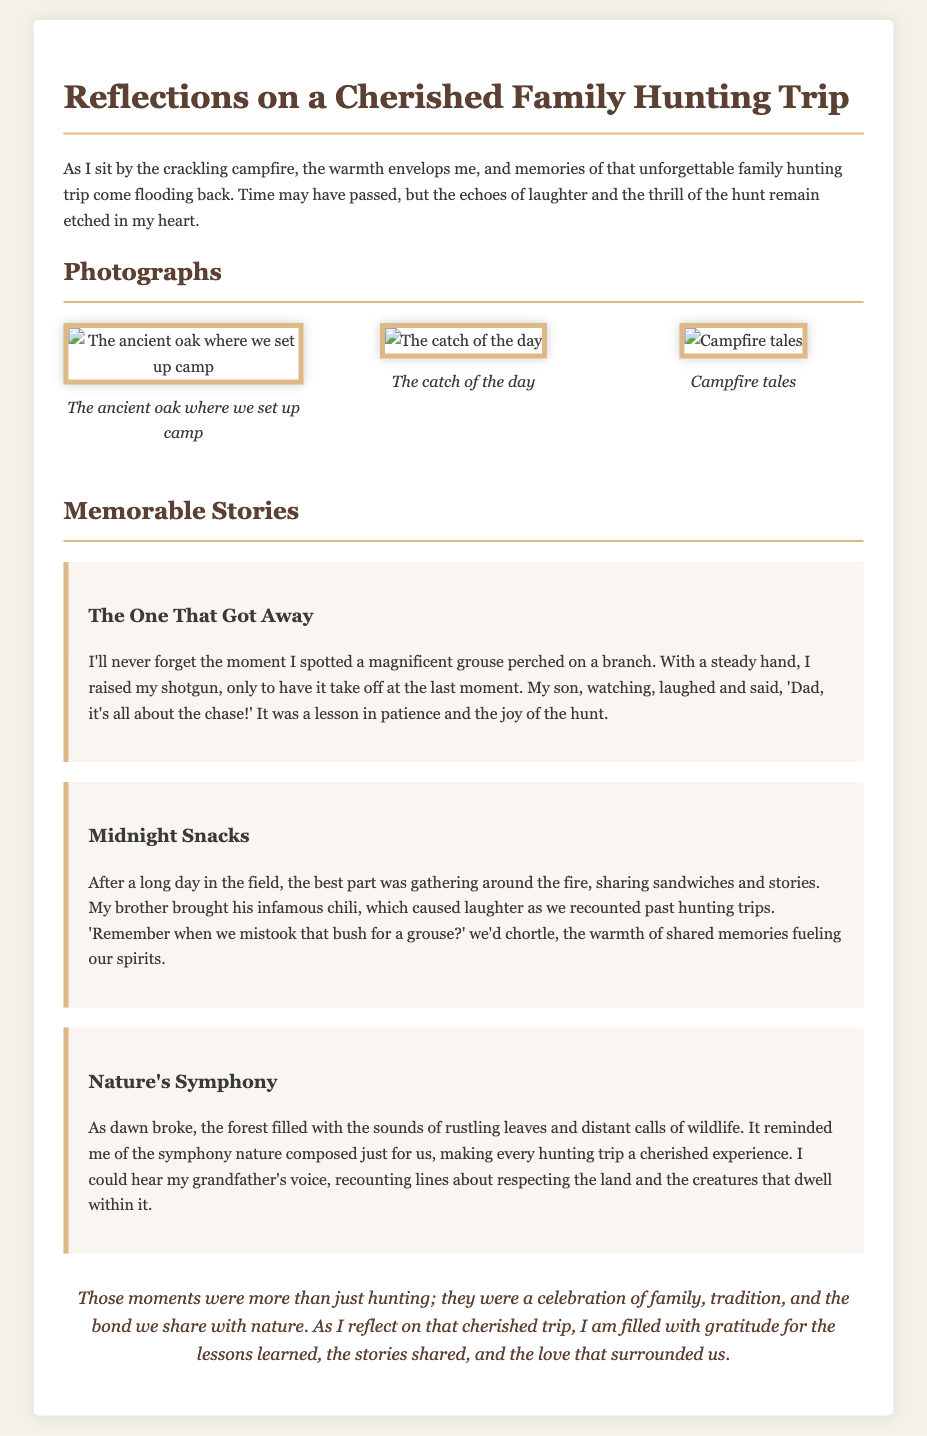What is the title of the document? The title is presented at the top of the document, summarizing the main theme of the content.
Answer: Reflections on a Cherished Family Hunting Trip Who took the photo of the ancient oak? The document does not mention specific photographers or authors of the photographs.
Answer: Not specified What was the catch of the day? The document includes a photograph with a caption referring to the successful hunt.
Answer: The catch of the day What did the brother bring for midnight snacks? It is mentioned in the story about midnight snacks that the brother brought a specific dish.
Answer: Chili What lesson did the narrator's son emphasize? This lesson reflects the essence of hunting, as explained in the narrative about the hunt.
Answer: It's all about the chase How did the narrator describe the sounds of dawn in the forest? The narrator reflects on the experience of listening to nature's sounds during the early hours, emphasizing its beauty.
Answer: Nature's Symphony What does the conclusion of the note emphasize? The conclusion encapsulates the overarching themes presented throughout the document, summarizing its essence.
Answer: Celebration of family, tradition, and the bond with nature How many memorable stories are shared in the document? The document includes a section dedicated to sharing experiences related to the hunting trip.
Answer: Three What year is implied by reflecting on the cherished trip? The document suggests a nostalgic look back, but does not specify an exact year.
Answer: Not specified 